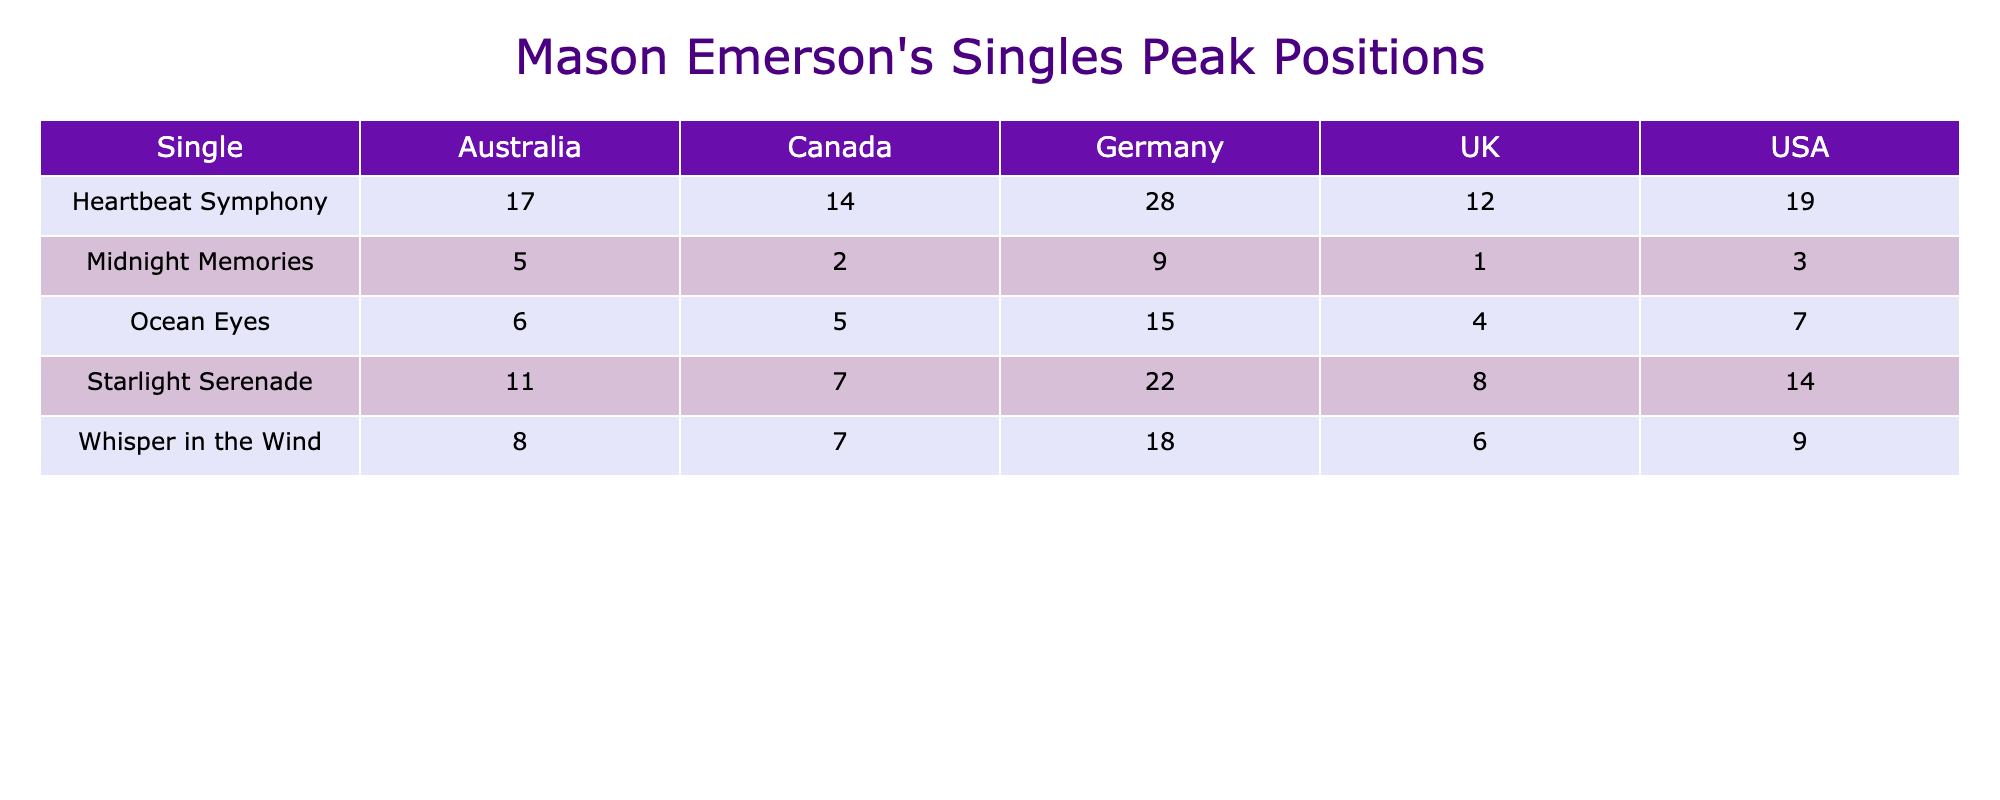What is the peak position of "Midnight Memories" in the UK? Looking at the table, I find "Midnight Memories" under the UK column which shows a peak position of 1.
Answer: 1 Which single had the highest peak position in Australia? By reviewing the data for Australia, "Midnight Memories" has the highest peak position at 5 compared to other singles listed.
Answer: 5 Did any single reach the peak position of 1 in Canada? Checking the table, "Midnight Memories" achieved a peak position of 2 in Canada; thus, no single reached 1 in Canada.
Answer: No What is the average peak position of "Ocean Eyes" across all countries? The peak positions for "Ocean Eyes" are 7 (USA), 4 (UK), 6 (Australia), 5 (Canada), and 15 (Germany). Summing these (7 + 4 + 6 + 5 + 15) gives 37. With 5 data points, the average is 37/5 = 7.4.
Answer: 7.4 Which single has the lowest peak position in Germany? Looking at the table, the single with the lowest peak position in Germany is "Heartbeat Symphony," which is positioned at 28.
Answer: 28 Is "Whisper in the Wind" the only single to peak in single digits in the USA? In the USA, the peak positions for the singles are 14, 3, 7, 19, and 9. The only single that is in the single-digit range is "Whisper in the Wind" at 9, making it not the only one as "Midnight Memories" at 3 also qualifies.
Answer: No What is the difference between the peak positions of "Starlight Serenade" in the UK and Germany? "Starlight Serenade" peaks at 8 in the UK and 22 in Germany. The difference is calculated as 22 - 8 = 14.
Answer: 14 Which single had a better peak position in Canada compared to Australia? By reviewing the table, "Midnight Memories" peaked at 2 in Canada and 5 in Australia, meaning it's not better in Canada. Therefore, "Ocean Eyes" is at 5 in Canada and 6 in Australia which also shows it didn’t have a better peak.
Answer: None What single met or exceeded a peak position of 10 across all countries? Analyzing the peak positions in the table, "Heartbeat Symphony" (19) and "Whisper in the Wind" (18) meet or exceed the position of 10 in several countries including the USA and Germany.
Answer: Heartbeat Symphony and Whisper in the Wind 